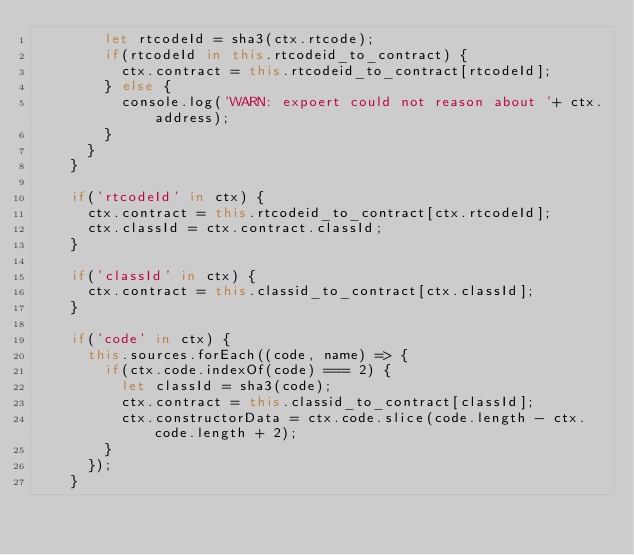Convert code to text. <code><loc_0><loc_0><loc_500><loc_500><_JavaScript_>        let rtcodeId = sha3(ctx.rtcode);
        if(rtcodeId in this.rtcodeid_to_contract) {
          ctx.contract = this.rtcodeid_to_contract[rtcodeId];
        } else {
          console.log('WARN: expoert could not reason about '+ ctx.address);
        }
      }
    }

    if('rtcodeId' in ctx) {
      ctx.contract = this.rtcodeid_to_contract[ctx.rtcodeId];
      ctx.classId = ctx.contract.classId;
    }

    if('classId' in ctx) {
      ctx.contract = this.classid_to_contract[ctx.classId];
    }

    if('code' in ctx) {
      this.sources.forEach((code, name) => {
        if(ctx.code.indexOf(code) === 2) {
          let classId = sha3(code);
          ctx.contract = this.classid_to_contract[classId];
          ctx.constructorData = ctx.code.slice(code.length - ctx.code.length + 2);
        }
      });
    }
</code> 